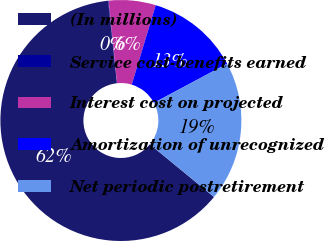Convert chart. <chart><loc_0><loc_0><loc_500><loc_500><pie_chart><fcel>(In millions)<fcel>Service cost-benefits earned<fcel>Interest cost on projected<fcel>Amortization of unrecognized<fcel>Net periodic postretirement<nl><fcel>62.36%<fcel>0.07%<fcel>6.29%<fcel>12.52%<fcel>18.75%<nl></chart> 